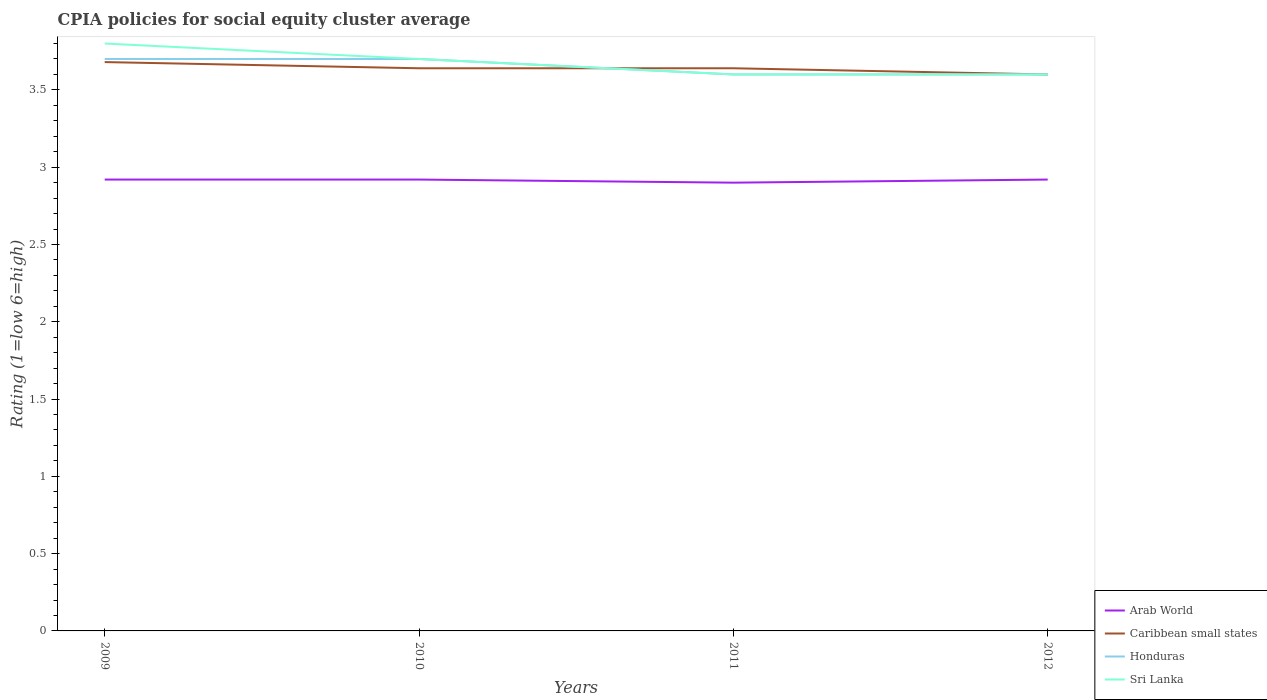Across all years, what is the maximum CPIA rating in Honduras?
Ensure brevity in your answer.  3.6. What is the total CPIA rating in Caribbean small states in the graph?
Provide a short and direct response. 0.04. What is the difference between the highest and the second highest CPIA rating in Honduras?
Your answer should be very brief. 0.1. What is the difference between the highest and the lowest CPIA rating in Caribbean small states?
Give a very brief answer. 1. Is the CPIA rating in Arab World strictly greater than the CPIA rating in Caribbean small states over the years?
Offer a terse response. Yes. Are the values on the major ticks of Y-axis written in scientific E-notation?
Your response must be concise. No. Where does the legend appear in the graph?
Provide a short and direct response. Bottom right. What is the title of the graph?
Offer a very short reply. CPIA policies for social equity cluster average. What is the label or title of the X-axis?
Offer a very short reply. Years. What is the Rating (1=low 6=high) in Arab World in 2009?
Your answer should be compact. 2.92. What is the Rating (1=low 6=high) in Caribbean small states in 2009?
Ensure brevity in your answer.  3.68. What is the Rating (1=low 6=high) of Honduras in 2009?
Give a very brief answer. 3.7. What is the Rating (1=low 6=high) in Sri Lanka in 2009?
Your answer should be very brief. 3.8. What is the Rating (1=low 6=high) of Arab World in 2010?
Your response must be concise. 2.92. What is the Rating (1=low 6=high) in Caribbean small states in 2010?
Offer a very short reply. 3.64. What is the Rating (1=low 6=high) of Sri Lanka in 2010?
Ensure brevity in your answer.  3.7. What is the Rating (1=low 6=high) of Arab World in 2011?
Provide a succinct answer. 2.9. What is the Rating (1=low 6=high) of Caribbean small states in 2011?
Offer a terse response. 3.64. What is the Rating (1=low 6=high) in Honduras in 2011?
Give a very brief answer. 3.6. What is the Rating (1=low 6=high) in Arab World in 2012?
Offer a very short reply. 2.92. What is the Rating (1=low 6=high) in Honduras in 2012?
Offer a very short reply. 3.6. What is the Rating (1=low 6=high) of Sri Lanka in 2012?
Offer a very short reply. 3.6. Across all years, what is the maximum Rating (1=low 6=high) of Arab World?
Your response must be concise. 2.92. Across all years, what is the maximum Rating (1=low 6=high) in Caribbean small states?
Provide a short and direct response. 3.68. Across all years, what is the maximum Rating (1=low 6=high) of Honduras?
Your answer should be very brief. 3.7. Across all years, what is the maximum Rating (1=low 6=high) of Sri Lanka?
Provide a succinct answer. 3.8. Across all years, what is the minimum Rating (1=low 6=high) of Caribbean small states?
Offer a very short reply. 3.6. Across all years, what is the minimum Rating (1=low 6=high) in Honduras?
Provide a short and direct response. 3.6. What is the total Rating (1=low 6=high) of Arab World in the graph?
Make the answer very short. 11.66. What is the total Rating (1=low 6=high) in Caribbean small states in the graph?
Your answer should be compact. 14.56. What is the difference between the Rating (1=low 6=high) of Caribbean small states in 2009 and that in 2010?
Your response must be concise. 0.04. What is the difference between the Rating (1=low 6=high) in Honduras in 2009 and that in 2010?
Your answer should be very brief. 0. What is the difference between the Rating (1=low 6=high) in Caribbean small states in 2009 and that in 2011?
Offer a terse response. 0.04. What is the difference between the Rating (1=low 6=high) of Sri Lanka in 2009 and that in 2011?
Offer a very short reply. 0.2. What is the difference between the Rating (1=low 6=high) in Arab World in 2010 and that in 2011?
Offer a terse response. 0.02. What is the difference between the Rating (1=low 6=high) in Caribbean small states in 2010 and that in 2011?
Your answer should be very brief. 0. What is the difference between the Rating (1=low 6=high) of Arab World in 2010 and that in 2012?
Keep it short and to the point. 0. What is the difference between the Rating (1=low 6=high) in Caribbean small states in 2010 and that in 2012?
Keep it short and to the point. 0.04. What is the difference between the Rating (1=low 6=high) in Arab World in 2011 and that in 2012?
Make the answer very short. -0.02. What is the difference between the Rating (1=low 6=high) in Honduras in 2011 and that in 2012?
Make the answer very short. 0. What is the difference between the Rating (1=low 6=high) in Sri Lanka in 2011 and that in 2012?
Ensure brevity in your answer.  0. What is the difference between the Rating (1=low 6=high) in Arab World in 2009 and the Rating (1=low 6=high) in Caribbean small states in 2010?
Ensure brevity in your answer.  -0.72. What is the difference between the Rating (1=low 6=high) of Arab World in 2009 and the Rating (1=low 6=high) of Honduras in 2010?
Provide a short and direct response. -0.78. What is the difference between the Rating (1=low 6=high) of Arab World in 2009 and the Rating (1=low 6=high) of Sri Lanka in 2010?
Your response must be concise. -0.78. What is the difference between the Rating (1=low 6=high) in Caribbean small states in 2009 and the Rating (1=low 6=high) in Honduras in 2010?
Your answer should be compact. -0.02. What is the difference between the Rating (1=low 6=high) in Caribbean small states in 2009 and the Rating (1=low 6=high) in Sri Lanka in 2010?
Your answer should be very brief. -0.02. What is the difference between the Rating (1=low 6=high) in Arab World in 2009 and the Rating (1=low 6=high) in Caribbean small states in 2011?
Keep it short and to the point. -0.72. What is the difference between the Rating (1=low 6=high) in Arab World in 2009 and the Rating (1=low 6=high) in Honduras in 2011?
Your answer should be very brief. -0.68. What is the difference between the Rating (1=low 6=high) of Arab World in 2009 and the Rating (1=low 6=high) of Sri Lanka in 2011?
Give a very brief answer. -0.68. What is the difference between the Rating (1=low 6=high) in Caribbean small states in 2009 and the Rating (1=low 6=high) in Honduras in 2011?
Offer a very short reply. 0.08. What is the difference between the Rating (1=low 6=high) of Arab World in 2009 and the Rating (1=low 6=high) of Caribbean small states in 2012?
Make the answer very short. -0.68. What is the difference between the Rating (1=low 6=high) of Arab World in 2009 and the Rating (1=low 6=high) of Honduras in 2012?
Give a very brief answer. -0.68. What is the difference between the Rating (1=low 6=high) of Arab World in 2009 and the Rating (1=low 6=high) of Sri Lanka in 2012?
Provide a succinct answer. -0.68. What is the difference between the Rating (1=low 6=high) in Arab World in 2010 and the Rating (1=low 6=high) in Caribbean small states in 2011?
Offer a terse response. -0.72. What is the difference between the Rating (1=low 6=high) of Arab World in 2010 and the Rating (1=low 6=high) of Honduras in 2011?
Your answer should be very brief. -0.68. What is the difference between the Rating (1=low 6=high) in Arab World in 2010 and the Rating (1=low 6=high) in Sri Lanka in 2011?
Make the answer very short. -0.68. What is the difference between the Rating (1=low 6=high) of Caribbean small states in 2010 and the Rating (1=low 6=high) of Honduras in 2011?
Offer a very short reply. 0.04. What is the difference between the Rating (1=low 6=high) of Caribbean small states in 2010 and the Rating (1=low 6=high) of Sri Lanka in 2011?
Offer a very short reply. 0.04. What is the difference between the Rating (1=low 6=high) of Arab World in 2010 and the Rating (1=low 6=high) of Caribbean small states in 2012?
Your answer should be very brief. -0.68. What is the difference between the Rating (1=low 6=high) in Arab World in 2010 and the Rating (1=low 6=high) in Honduras in 2012?
Make the answer very short. -0.68. What is the difference between the Rating (1=low 6=high) in Arab World in 2010 and the Rating (1=low 6=high) in Sri Lanka in 2012?
Offer a terse response. -0.68. What is the difference between the Rating (1=low 6=high) in Arab World in 2011 and the Rating (1=low 6=high) in Caribbean small states in 2012?
Provide a succinct answer. -0.7. What is the difference between the Rating (1=low 6=high) in Arab World in 2011 and the Rating (1=low 6=high) in Honduras in 2012?
Your answer should be compact. -0.7. What is the difference between the Rating (1=low 6=high) of Arab World in 2011 and the Rating (1=low 6=high) of Sri Lanka in 2012?
Provide a short and direct response. -0.7. What is the difference between the Rating (1=low 6=high) in Caribbean small states in 2011 and the Rating (1=low 6=high) in Sri Lanka in 2012?
Offer a terse response. 0.04. What is the average Rating (1=low 6=high) in Arab World per year?
Provide a short and direct response. 2.92. What is the average Rating (1=low 6=high) of Caribbean small states per year?
Your answer should be very brief. 3.64. What is the average Rating (1=low 6=high) of Honduras per year?
Your answer should be compact. 3.65. What is the average Rating (1=low 6=high) in Sri Lanka per year?
Ensure brevity in your answer.  3.67. In the year 2009, what is the difference between the Rating (1=low 6=high) of Arab World and Rating (1=low 6=high) of Caribbean small states?
Ensure brevity in your answer.  -0.76. In the year 2009, what is the difference between the Rating (1=low 6=high) of Arab World and Rating (1=low 6=high) of Honduras?
Your answer should be very brief. -0.78. In the year 2009, what is the difference between the Rating (1=low 6=high) in Arab World and Rating (1=low 6=high) in Sri Lanka?
Your response must be concise. -0.88. In the year 2009, what is the difference between the Rating (1=low 6=high) in Caribbean small states and Rating (1=low 6=high) in Honduras?
Offer a very short reply. -0.02. In the year 2009, what is the difference between the Rating (1=low 6=high) in Caribbean small states and Rating (1=low 6=high) in Sri Lanka?
Your response must be concise. -0.12. In the year 2009, what is the difference between the Rating (1=low 6=high) of Honduras and Rating (1=low 6=high) of Sri Lanka?
Your response must be concise. -0.1. In the year 2010, what is the difference between the Rating (1=low 6=high) in Arab World and Rating (1=low 6=high) in Caribbean small states?
Provide a succinct answer. -0.72. In the year 2010, what is the difference between the Rating (1=low 6=high) in Arab World and Rating (1=low 6=high) in Honduras?
Offer a terse response. -0.78. In the year 2010, what is the difference between the Rating (1=low 6=high) in Arab World and Rating (1=low 6=high) in Sri Lanka?
Keep it short and to the point. -0.78. In the year 2010, what is the difference between the Rating (1=low 6=high) in Caribbean small states and Rating (1=low 6=high) in Honduras?
Give a very brief answer. -0.06. In the year 2010, what is the difference between the Rating (1=low 6=high) in Caribbean small states and Rating (1=low 6=high) in Sri Lanka?
Ensure brevity in your answer.  -0.06. In the year 2011, what is the difference between the Rating (1=low 6=high) in Arab World and Rating (1=low 6=high) in Caribbean small states?
Provide a succinct answer. -0.74. In the year 2011, what is the difference between the Rating (1=low 6=high) of Arab World and Rating (1=low 6=high) of Honduras?
Your response must be concise. -0.7. In the year 2011, what is the difference between the Rating (1=low 6=high) of Honduras and Rating (1=low 6=high) of Sri Lanka?
Your answer should be compact. 0. In the year 2012, what is the difference between the Rating (1=low 6=high) in Arab World and Rating (1=low 6=high) in Caribbean small states?
Your answer should be very brief. -0.68. In the year 2012, what is the difference between the Rating (1=low 6=high) of Arab World and Rating (1=low 6=high) of Honduras?
Your answer should be very brief. -0.68. In the year 2012, what is the difference between the Rating (1=low 6=high) in Arab World and Rating (1=low 6=high) in Sri Lanka?
Offer a terse response. -0.68. In the year 2012, what is the difference between the Rating (1=low 6=high) of Honduras and Rating (1=low 6=high) of Sri Lanka?
Your response must be concise. 0. What is the ratio of the Rating (1=low 6=high) of Honduras in 2009 to that in 2010?
Provide a short and direct response. 1. What is the ratio of the Rating (1=low 6=high) of Sri Lanka in 2009 to that in 2010?
Your answer should be compact. 1.03. What is the ratio of the Rating (1=low 6=high) in Arab World in 2009 to that in 2011?
Offer a very short reply. 1.01. What is the ratio of the Rating (1=low 6=high) of Caribbean small states in 2009 to that in 2011?
Ensure brevity in your answer.  1.01. What is the ratio of the Rating (1=low 6=high) of Honduras in 2009 to that in 2011?
Your answer should be very brief. 1.03. What is the ratio of the Rating (1=low 6=high) of Sri Lanka in 2009 to that in 2011?
Give a very brief answer. 1.06. What is the ratio of the Rating (1=low 6=high) of Arab World in 2009 to that in 2012?
Ensure brevity in your answer.  1. What is the ratio of the Rating (1=low 6=high) in Caribbean small states in 2009 to that in 2012?
Your answer should be compact. 1.02. What is the ratio of the Rating (1=low 6=high) of Honduras in 2009 to that in 2012?
Make the answer very short. 1.03. What is the ratio of the Rating (1=low 6=high) of Sri Lanka in 2009 to that in 2012?
Give a very brief answer. 1.06. What is the ratio of the Rating (1=low 6=high) in Caribbean small states in 2010 to that in 2011?
Your answer should be very brief. 1. What is the ratio of the Rating (1=low 6=high) in Honduras in 2010 to that in 2011?
Provide a succinct answer. 1.03. What is the ratio of the Rating (1=low 6=high) in Sri Lanka in 2010 to that in 2011?
Give a very brief answer. 1.03. What is the ratio of the Rating (1=low 6=high) in Caribbean small states in 2010 to that in 2012?
Provide a succinct answer. 1.01. What is the ratio of the Rating (1=low 6=high) of Honduras in 2010 to that in 2012?
Offer a terse response. 1.03. What is the ratio of the Rating (1=low 6=high) of Sri Lanka in 2010 to that in 2012?
Your response must be concise. 1.03. What is the ratio of the Rating (1=low 6=high) of Arab World in 2011 to that in 2012?
Make the answer very short. 0.99. What is the ratio of the Rating (1=low 6=high) in Caribbean small states in 2011 to that in 2012?
Make the answer very short. 1.01. What is the ratio of the Rating (1=low 6=high) of Honduras in 2011 to that in 2012?
Offer a very short reply. 1. What is the ratio of the Rating (1=low 6=high) in Sri Lanka in 2011 to that in 2012?
Make the answer very short. 1. What is the difference between the highest and the second highest Rating (1=low 6=high) of Caribbean small states?
Ensure brevity in your answer.  0.04. What is the difference between the highest and the lowest Rating (1=low 6=high) of Arab World?
Your answer should be very brief. 0.02. What is the difference between the highest and the lowest Rating (1=low 6=high) in Honduras?
Provide a short and direct response. 0.1. What is the difference between the highest and the lowest Rating (1=low 6=high) of Sri Lanka?
Your response must be concise. 0.2. 